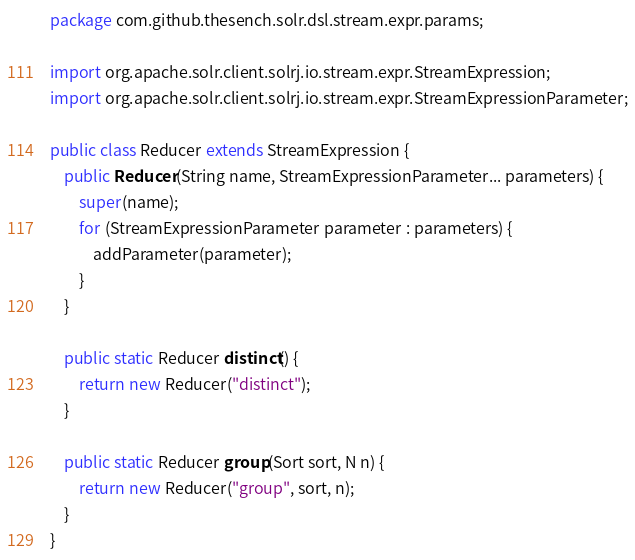<code> <loc_0><loc_0><loc_500><loc_500><_Java_>package com.github.thesench.solr.dsl.stream.expr.params;

import org.apache.solr.client.solrj.io.stream.expr.StreamExpression;
import org.apache.solr.client.solrj.io.stream.expr.StreamExpressionParameter;

public class Reducer extends StreamExpression {
    public Reducer(String name, StreamExpressionParameter... parameters) {
        super(name);
        for (StreamExpressionParameter parameter : parameters) {
            addParameter(parameter);
        }
    }

    public static Reducer distinct() {
        return new Reducer("distinct");
    }

    public static Reducer group(Sort sort, N n) {
        return new Reducer("group", sort, n);
    }
}
</code> 